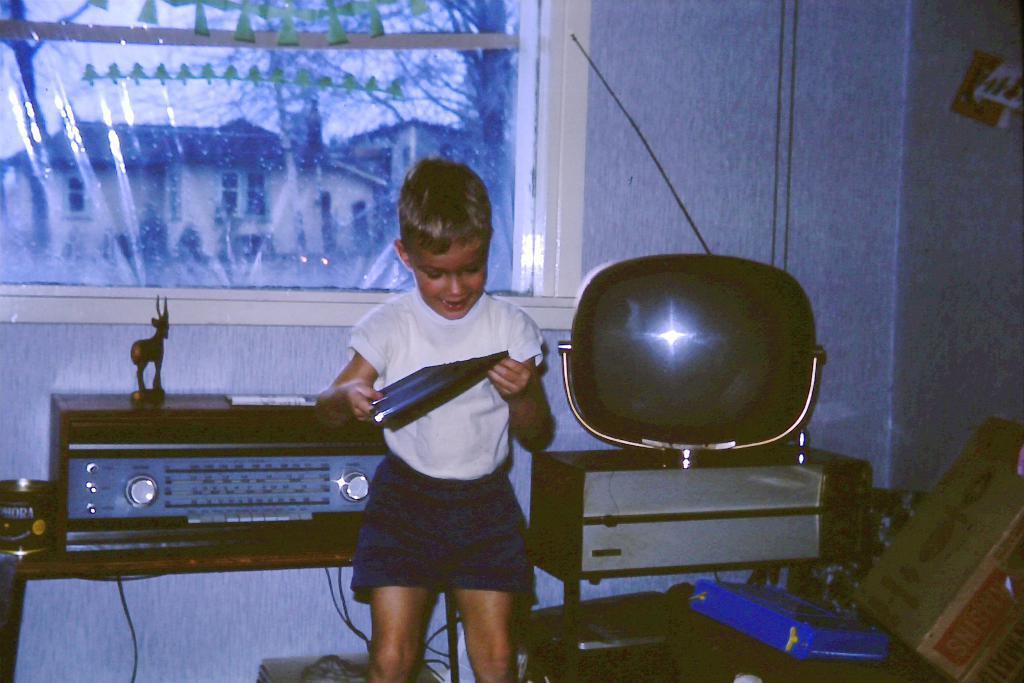Please provide a concise description of this image. There is a boy wearing a white T- shirt and blue short standing. This is a table with a tape recorder placed on it. This looks like a television is placed on a small table. At the right corner of the image I can see a card board and a small toy is placed above the tape recorder. At the background I can see a window. 